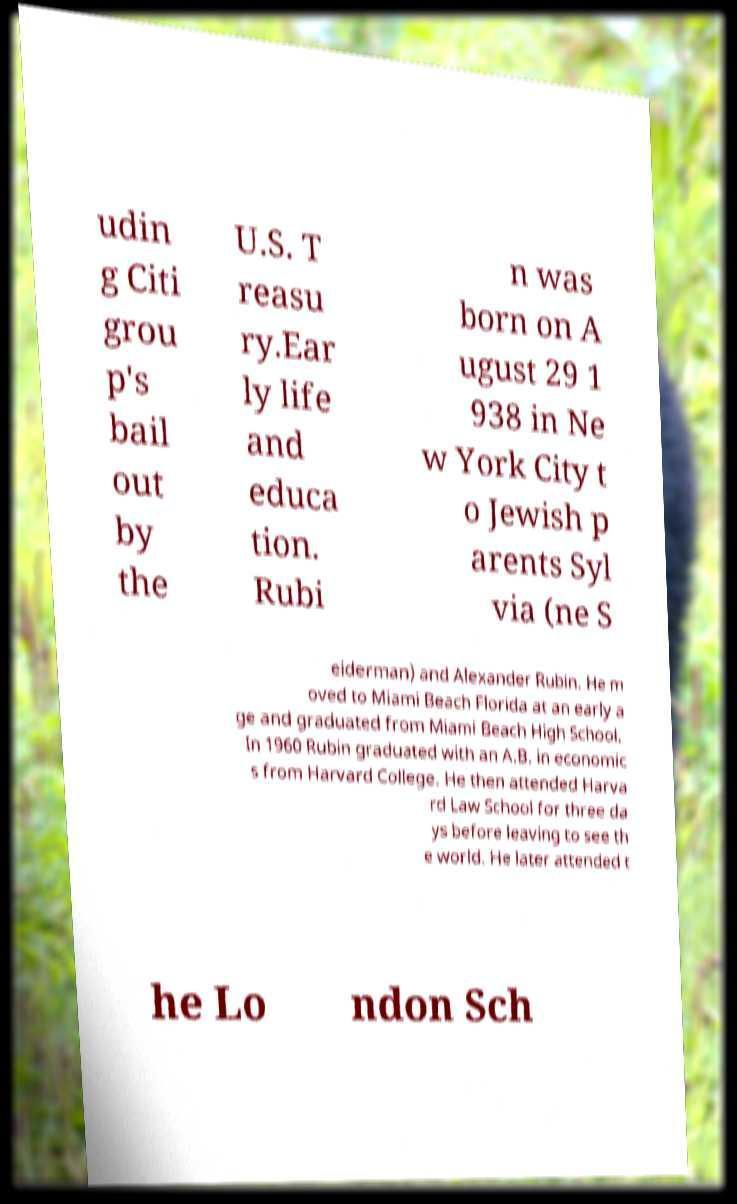Can you read and provide the text displayed in the image?This photo seems to have some interesting text. Can you extract and type it out for me? udin g Citi grou p's bail out by the U.S. T reasu ry.Ear ly life and educa tion. Rubi n was born on A ugust 29 1 938 in Ne w York City t o Jewish p arents Syl via (ne S eiderman) and Alexander Rubin. He m oved to Miami Beach Florida at an early a ge and graduated from Miami Beach High School. In 1960 Rubin graduated with an A.B. in economic s from Harvard College. He then attended Harva rd Law School for three da ys before leaving to see th e world. He later attended t he Lo ndon Sch 